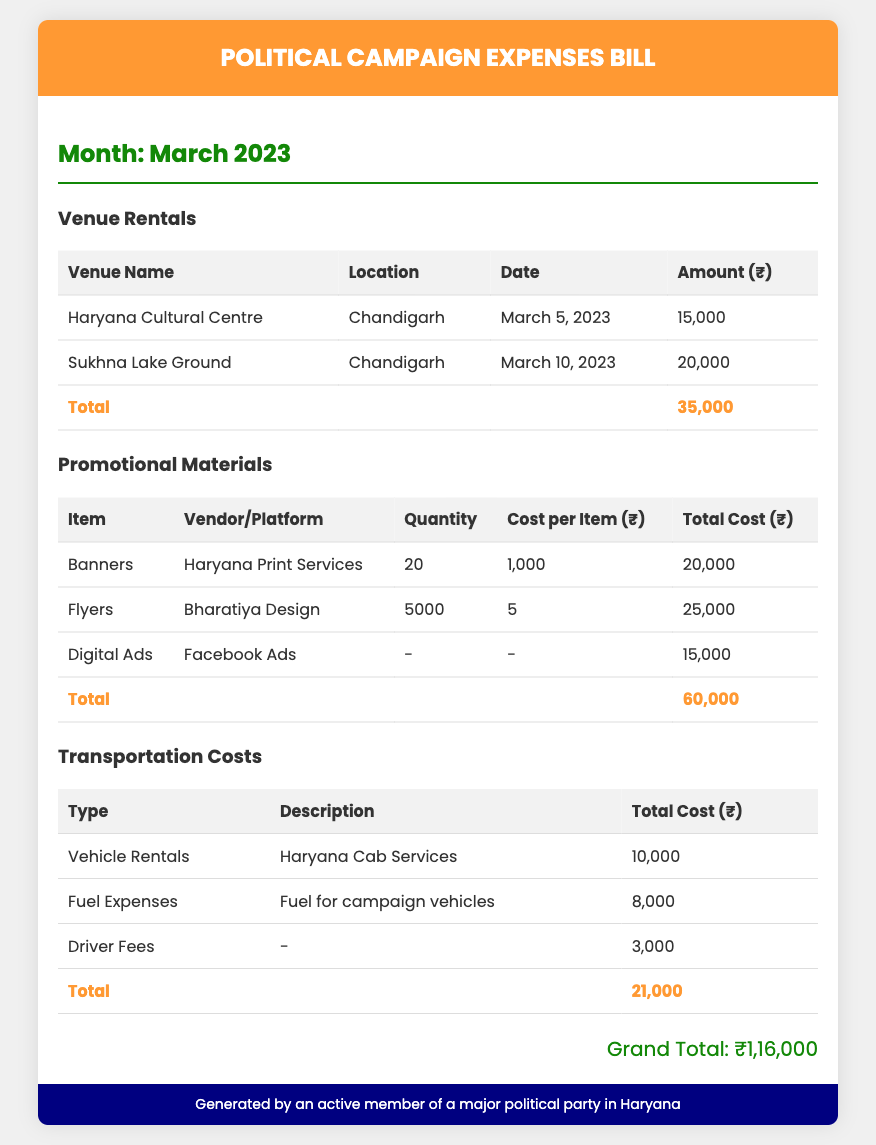What is the total expense for venue rentals? The total expense for venue rentals is given in the document and is found by summing the amounts listed under that category, which are ₹15,000 and ₹20,000.
Answer: ₹35,000 Who provided the banners for promotional materials? The document specifies the vendor for banners in the promotional materials section, which is Haryana Print Services.
Answer: Haryana Print Services How much was spent on fuel expenses? The document lists the fuel expenses as a separate line item under transportation costs, which amounts to ₹8,000.
Answer: ₹8,000 What venue was rented on March 10, 2023? The document provides details of venue rentals, and the venue rented on March 10, 2023, is Sukhna Lake Ground.
Answer: Sukhna Lake Ground What is the total cost of promotional materials? The total cost of promotional materials is calculated by adding all the costs listed under that section: ₹20,000, ₹25,000, and ₹15,000.
Answer: ₹60,000 What is the grand total of all expenses? The grand total is stated at the end of the document and represents the complete sum of all expenses categorized.
Answer: ₹1,16,000 Which organization provided the vehicle rentals? The document specifies that Haryana Cab Services was the provider for vehicle rentals mentioned under transportation costs.
Answer: Haryana Cab Services How many flyers were printed? The number of flyers printed is noted in the promotional materials section, which is 5,000.
Answer: 5000 